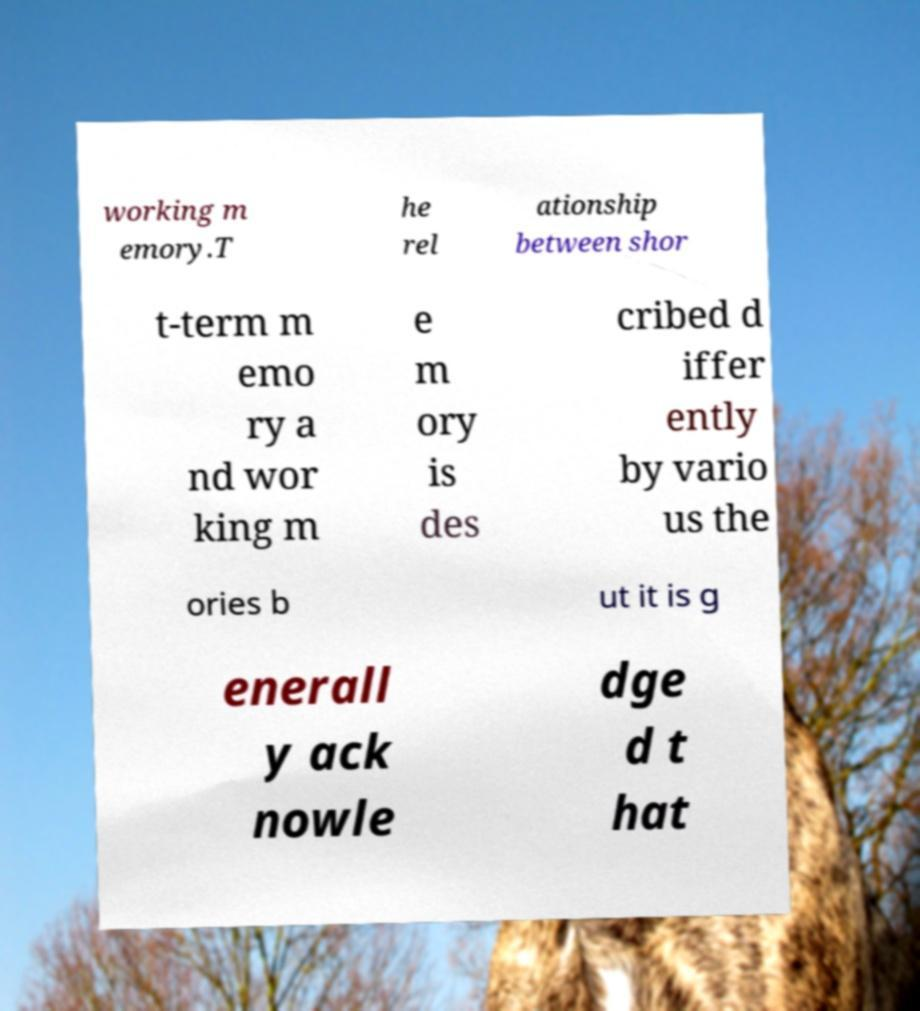Can you read and provide the text displayed in the image?This photo seems to have some interesting text. Can you extract and type it out for me? working m emory.T he rel ationship between shor t-term m emo ry a nd wor king m e m ory is des cribed d iffer ently by vario us the ories b ut it is g enerall y ack nowle dge d t hat 